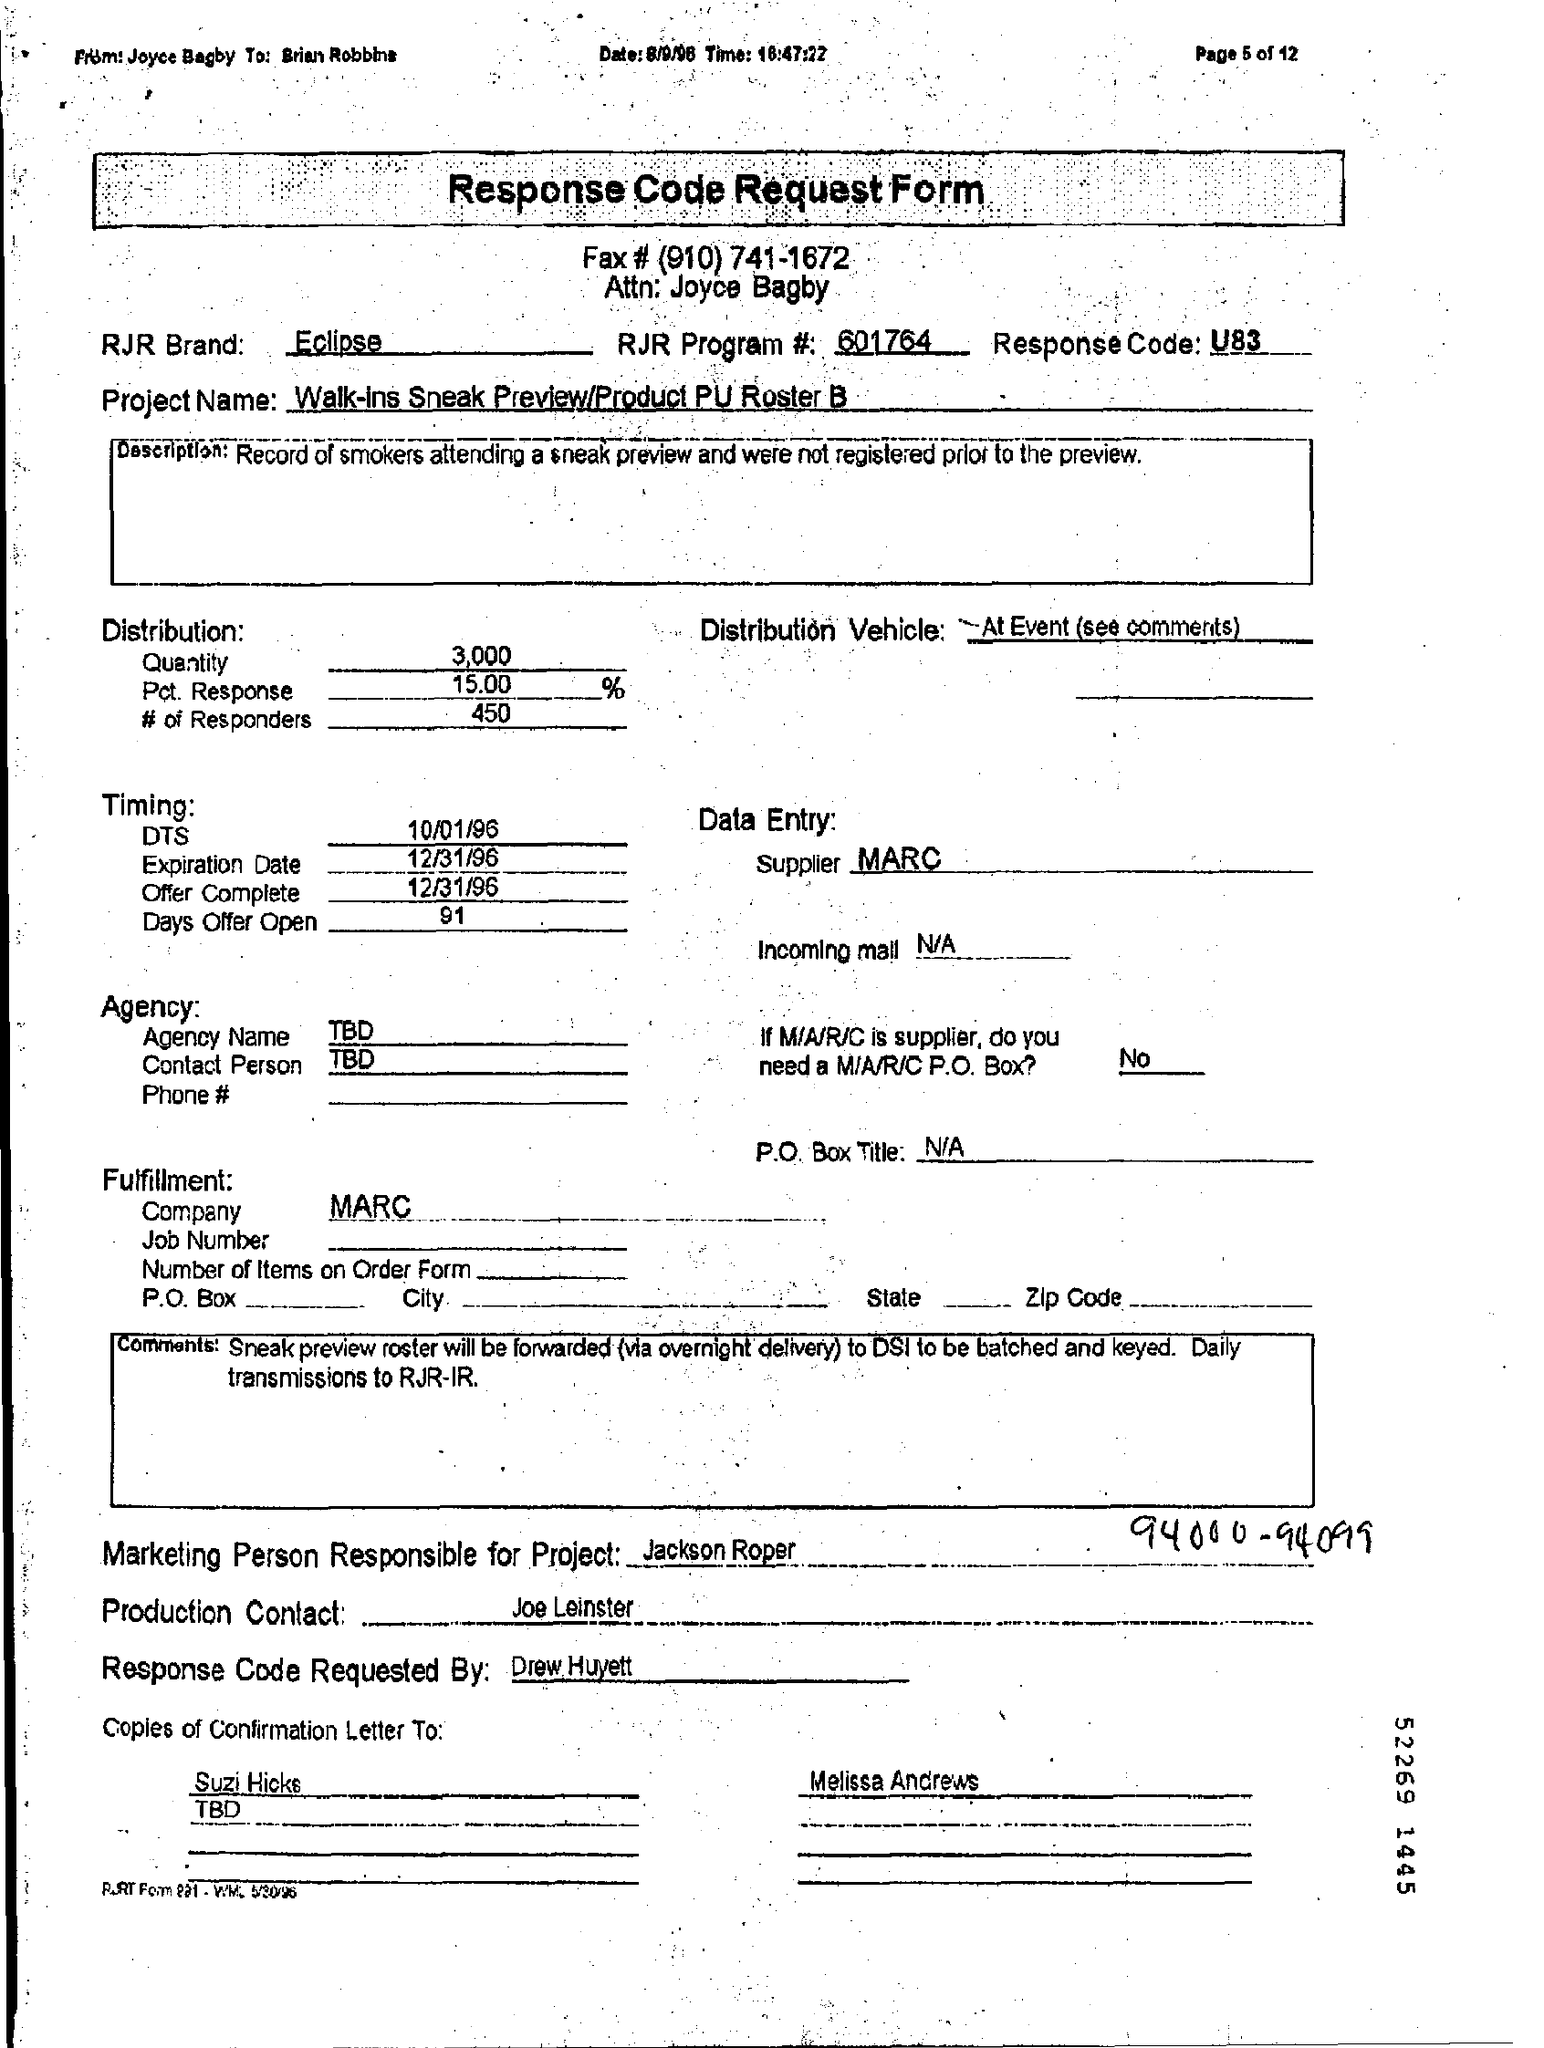What is written in the Letter Head ?
Make the answer very short. Response Code Request Form. What is the Fax Number ?
Ensure brevity in your answer.  #(910) 741-1672. What is the RJR Program Number ?
Your answer should be compact. 601764. What is the Response Code ?
Ensure brevity in your answer.  U83. What is the Expiration Date ?
Provide a short and direct response. 12/31/96. Who is the Supplier ?
Provide a succinct answer. MARC. What is written in the Distribution Vehicle Field ?
Your answer should be compact. At event (see comments). 